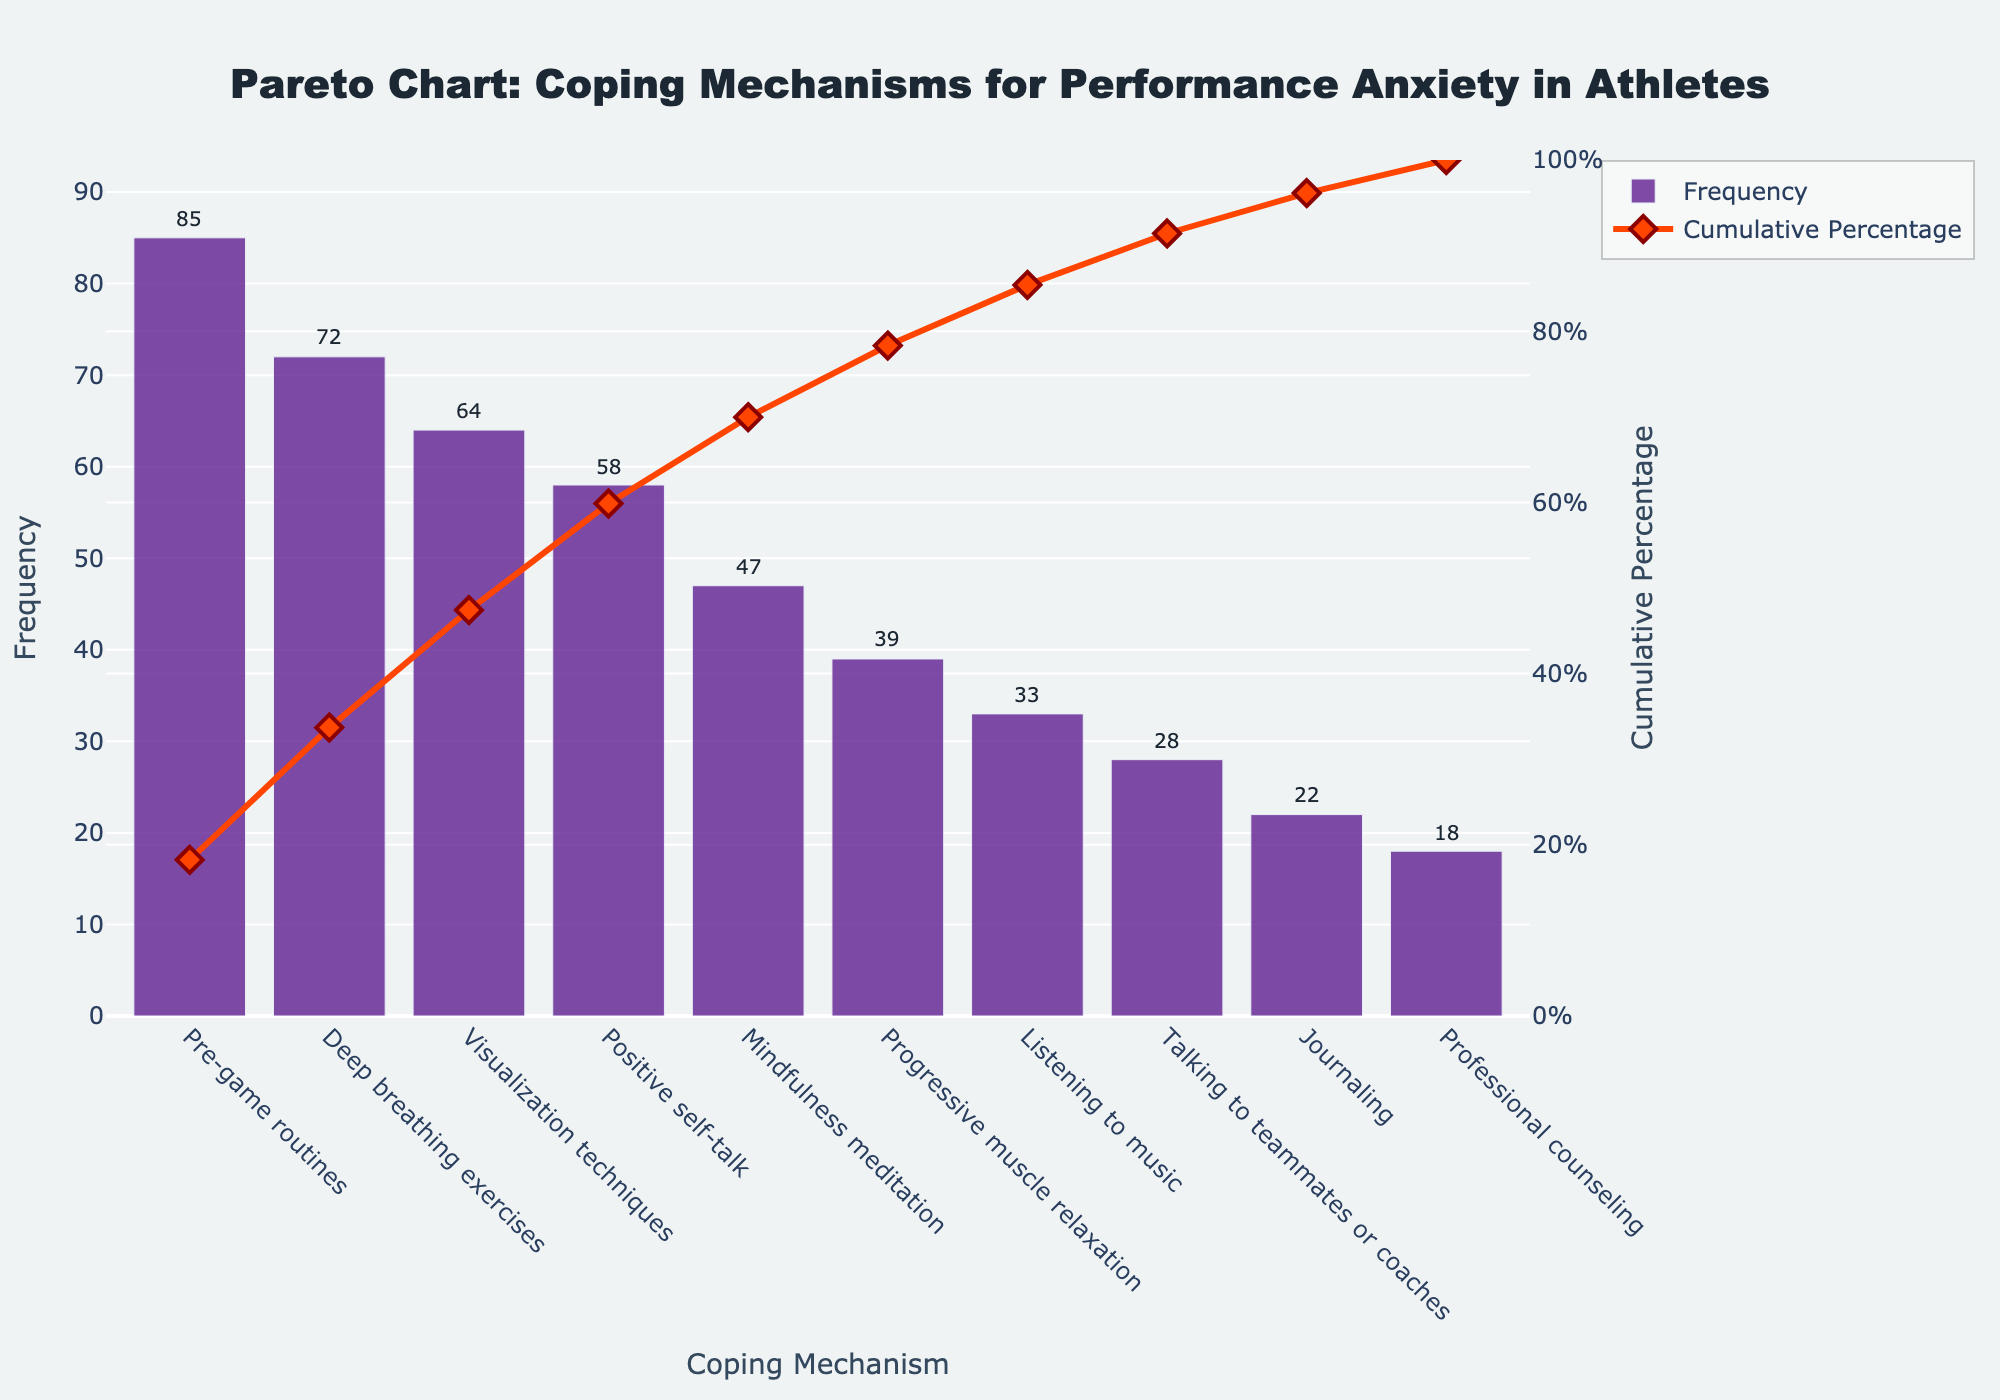What is the title of the figure? The title of the figure is mentioned at the top and states what the plot is about.
Answer: Pareto Chart: Coping Mechanisms for Performance Anxiety in Athletes Which coping mechanism has the highest frequency? Look for the bar that is the tallest in the bar chart, which indicates the coping mechanism with the highest frequency.
Answer: Pre-game routines Which coping mechanism has the lowest frequency? Identify the shortest bar in the bar chart to determine which coping mechanism has the lowest frequency.
Answer: Professional counseling How many coping mechanisms have a frequency of 40 or more? Count the number of bars that have a frequency value of 40 or more.
Answer: 6 What is the cumulative percentage for "Listening to music"? Follow the line chart and hover over the point corresponding to "Listening to music" to find the cumulative percentage.
Answer: 92% What is the cumulative frequency after the top three coping mechanisms? Sum the frequencies of the top three mechanisms and then divide by the total frequency, converting the value to a percentage.
Answer: 75% How does the frequency of "Deep breathing exercises" compare to "Progressive muscle relaxation"? Compare the height of the bars corresponding to "Deep breathing exercises" and "Progressive muscle relaxation".
Answer: Deep breathing exercises have a higher frequency What is the range of the y-axis for frequency? Check the values specified on the frequency y-axis, noting the minimum and maximum limits.
Answer: 0 to approximately 100 What is the frequency difference between "Mindfulness meditation" and "Talking to teammates or coaches"? Subtract the frequency of "Talking to teammates or coaches" from the frequency of "Mindfulness meditation".
Answer: 19 Which coping mechanisms contribute to over 50% of the cumulative frequency? Identify the bars up to the point where the cumulative percentage surpasses 50%.
Answer: Pre-game routines and deep breathing exercises 